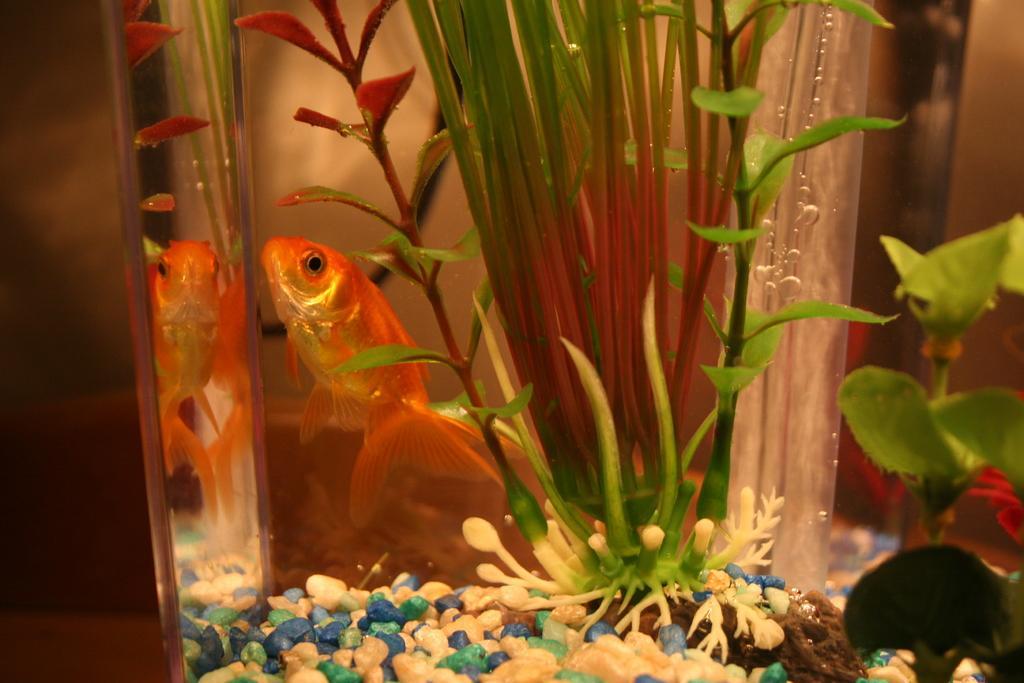What is the main feature of the image? There is an aquarium in the image. What can be found inside the aquarium? There are plants, stones, and a fish inside the aquarium. What type of thread is being used by the fish to communicate with the plants in the image? There is no thread present in the image, and the fish is not communicating with the plants. 